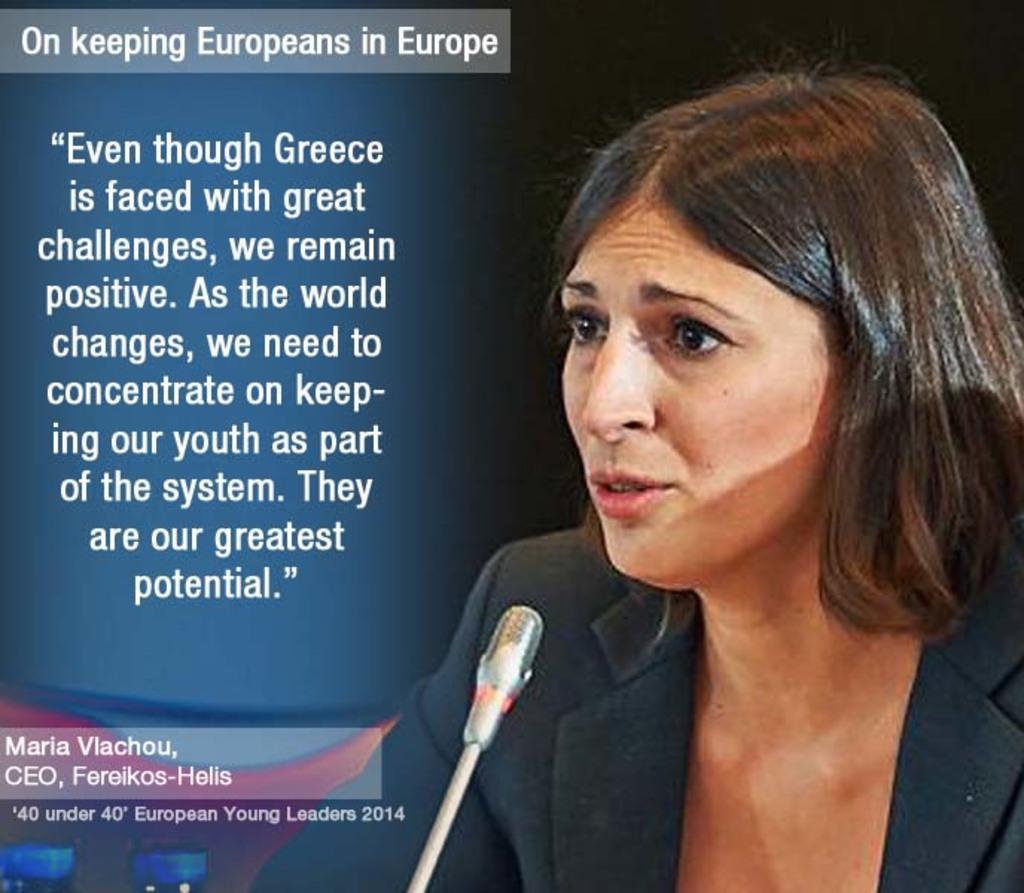In one or two sentences, can you explain what this image depicts? In this image I can see a woman on the right side and I can see she is wearing a black blazer. I can also see a mic in the front of her and on the left side of this image I can see something is written. 